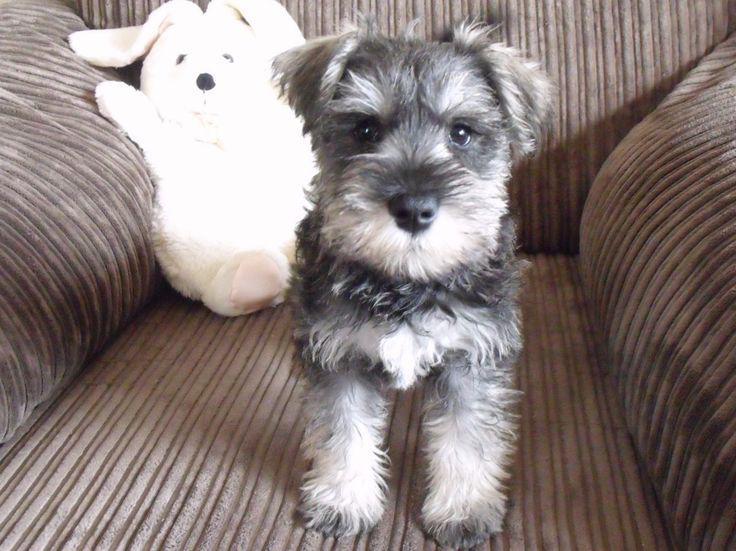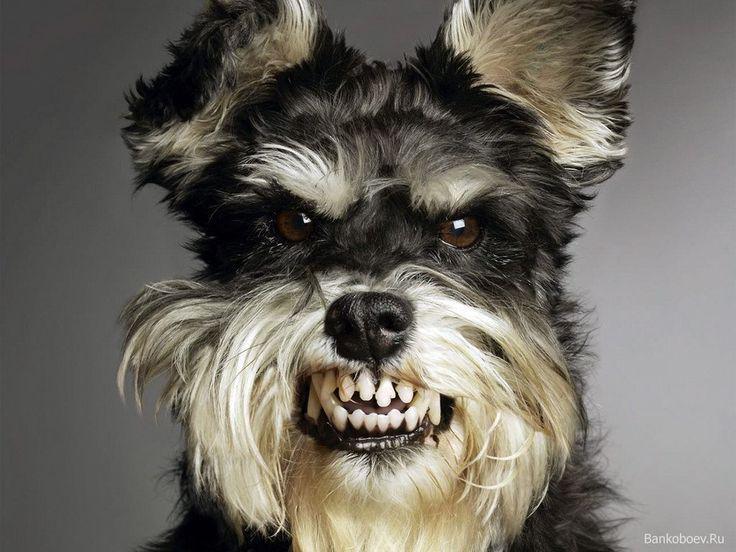The first image is the image on the left, the second image is the image on the right. For the images shown, is this caption "Some type of animal figure is behind a forward-turned schnauzer dog in the left image." true? Answer yes or no. Yes. The first image is the image on the left, the second image is the image on the right. Assess this claim about the two images: "At least one of the dogs has its mouth open.". Correct or not? Answer yes or no. Yes. 